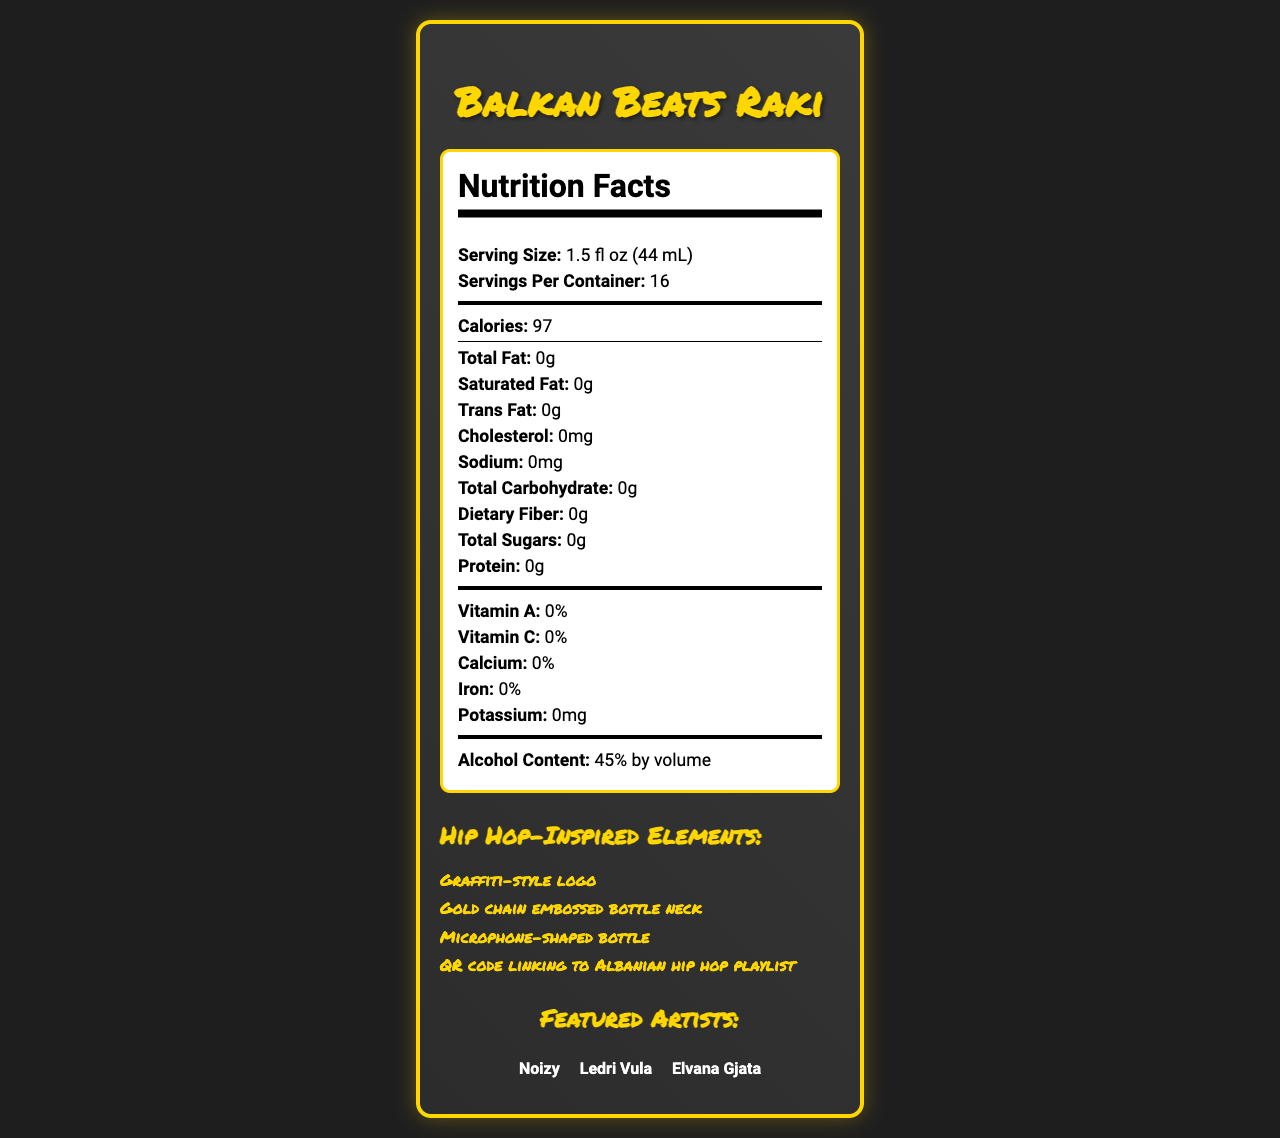what is the serving size of Balkan Beats Raki? The document clearly lists the serving size as 1.5 fl oz (44 mL).
Answer: 1.5 fl oz (44 mL) how many servings per container are there? It is stated in the document that there are 16 servings per container.
Answer: 16 how many calories does one serving of Balkan Beats Raki contain? According to the document, one serving contains 97 calories.
Answer: 97 what is the alcohol content by volume in Balkan Beats Raki? The alcohol content is listed as 45% by volume in the document.
Answer: 45% by volume name the four hip hop-inspired elements featured in the packaging The document lists these four hip hop-inspired elements under a dedicated section.
Answer: Graffiti-style logo, Gold chain embossed bottle neck, Microphone-shaped bottle, QR code linking to Albanian hip hop playlist which of the following ingredients is included in the product? A. Sugar B. Anise C. Wheat D. Corn The ingredients listed are "Distilled grape pomace," "Anise," and "Water."
Answer: B which artist is not featured on this product? A. Noizy B. Ledri Vula C. Elvana Gjata D. Yll Limani The featured artists listed are Noizy, Ledri Vula, and Elvana Gjata; Yll Limani is not listed.
Answer: D is the bottle made from recycled materials? The sustainability information mentions that the bottle is made from 30% recycled glass.
Answer: Yes summarize the key elements and features of the Balkan Beats Raki document This summary captures the main features and details from the document, including nutritional information, packaging elements, artist features, sustainability information, and awards.
Answer: Balkan Beats Raki is a traditional Albanian raki liquor with hip hop-inspired packaging. It has 97 calories per serving, contains no fat, cholesterol, sodium, sugar, or protein, and has an alcohol content of 45% by volume. The bottle features unique design elements like a graffiti-style logo, a gold chain embossed bottle neck, a microphone-shaped bottle, and a QR code linking to an Albanian hip hop playlist. The bottle is made from 30% recycled glass, and the product has won several awards, including a Gold Medal at the Balkan Spirits Competition in 2022 and Best Packaging Design at the Albanian Beverage Awards in 2023. how much calcium is in one serving of Balkan Beats Raki? The document states that there is 0% calcium in one serving.
Answer: 0% can we determine the price of Balkan Beats Raki from this document? The document does not provide any pricing details for the product.
Answer: Not enough information who is the manufacturer of Balkan Beats Raki? According to the document, the manufacturer is listed as Tirana Distillery Co.
Answer: Tirana Distillery Co. 